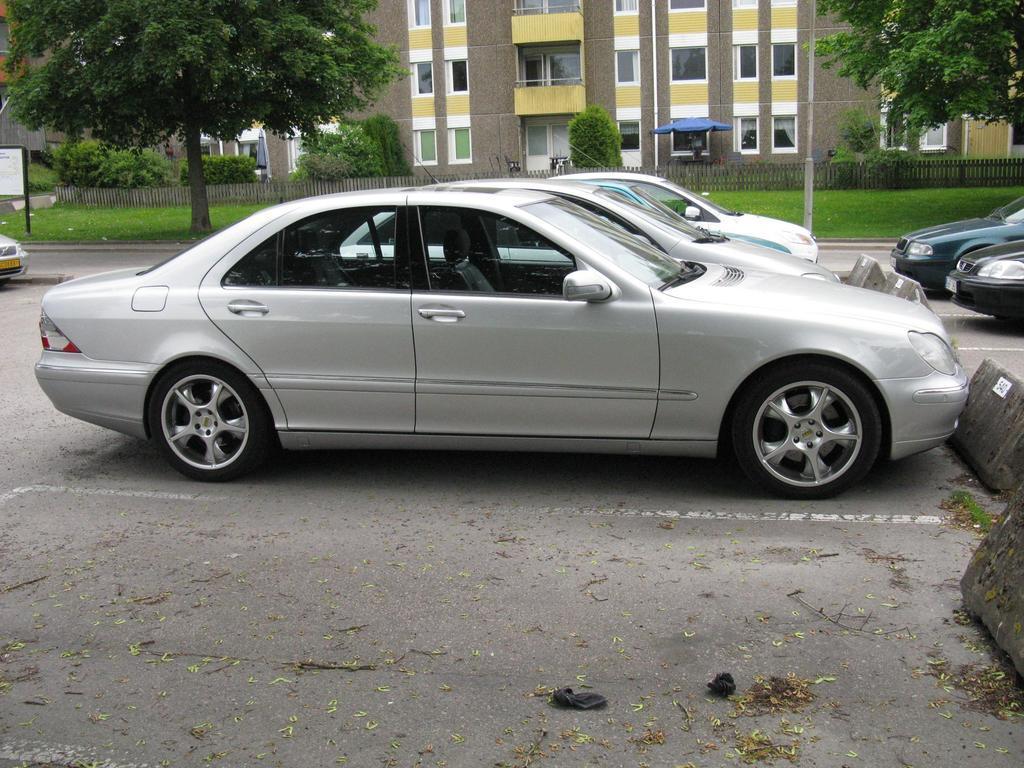Please provide a concise description of this image. In this image, in the middle, we can see few cars which are placed on the road. On the right side, we can also see car, trees. On the left side, we can also see trees. In the background, we can see some trees, building, plants, glass window. At the bottom, we can see a grass and a road. 